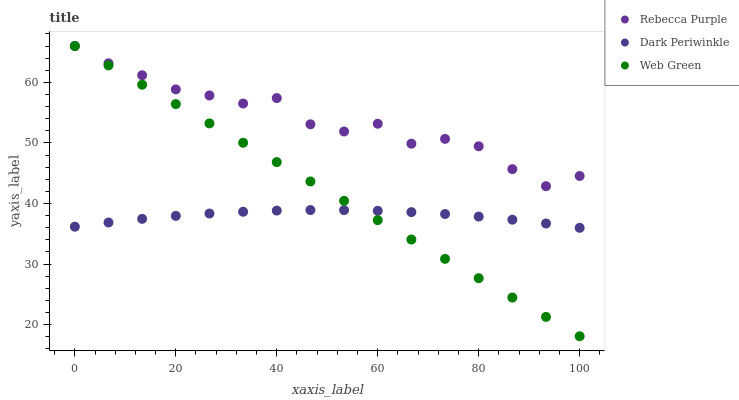Does Dark Periwinkle have the minimum area under the curve?
Answer yes or no. Yes. Does Rebecca Purple have the maximum area under the curve?
Answer yes or no. Yes. Does Web Green have the minimum area under the curve?
Answer yes or no. No. Does Web Green have the maximum area under the curve?
Answer yes or no. No. Is Web Green the smoothest?
Answer yes or no. Yes. Is Rebecca Purple the roughest?
Answer yes or no. Yes. Is Dark Periwinkle the smoothest?
Answer yes or no. No. Is Dark Periwinkle the roughest?
Answer yes or no. No. Does Web Green have the lowest value?
Answer yes or no. Yes. Does Dark Periwinkle have the lowest value?
Answer yes or no. No. Does Web Green have the highest value?
Answer yes or no. Yes. Does Dark Periwinkle have the highest value?
Answer yes or no. No. Is Dark Periwinkle less than Rebecca Purple?
Answer yes or no. Yes. Is Rebecca Purple greater than Dark Periwinkle?
Answer yes or no. Yes. Does Web Green intersect Dark Periwinkle?
Answer yes or no. Yes. Is Web Green less than Dark Periwinkle?
Answer yes or no. No. Is Web Green greater than Dark Periwinkle?
Answer yes or no. No. Does Dark Periwinkle intersect Rebecca Purple?
Answer yes or no. No. 